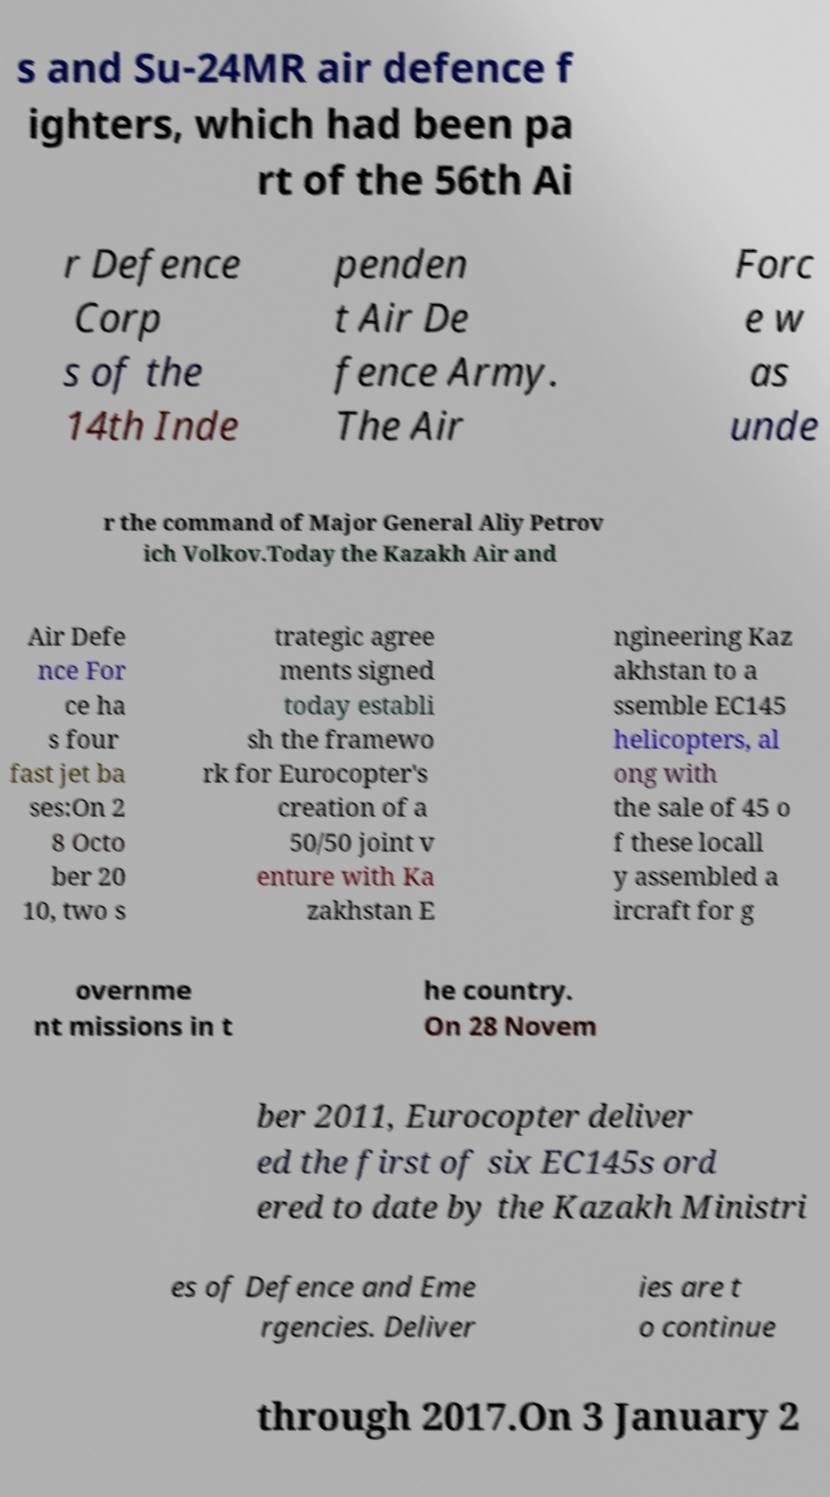I need the written content from this picture converted into text. Can you do that? s and Su-24MR air defence f ighters, which had been pa rt of the 56th Ai r Defence Corp s of the 14th Inde penden t Air De fence Army. The Air Forc e w as unde r the command of Major General Aliy Petrov ich Volkov.Today the Kazakh Air and Air Defe nce For ce ha s four fast jet ba ses:On 2 8 Octo ber 20 10, two s trategic agree ments signed today establi sh the framewo rk for Eurocopter's creation of a 50/50 joint v enture with Ka zakhstan E ngineering Kaz akhstan to a ssemble EC145 helicopters, al ong with the sale of 45 o f these locall y assembled a ircraft for g overnme nt missions in t he country. On 28 Novem ber 2011, Eurocopter deliver ed the first of six EC145s ord ered to date by the Kazakh Ministri es of Defence and Eme rgencies. Deliver ies are t o continue through 2017.On 3 January 2 